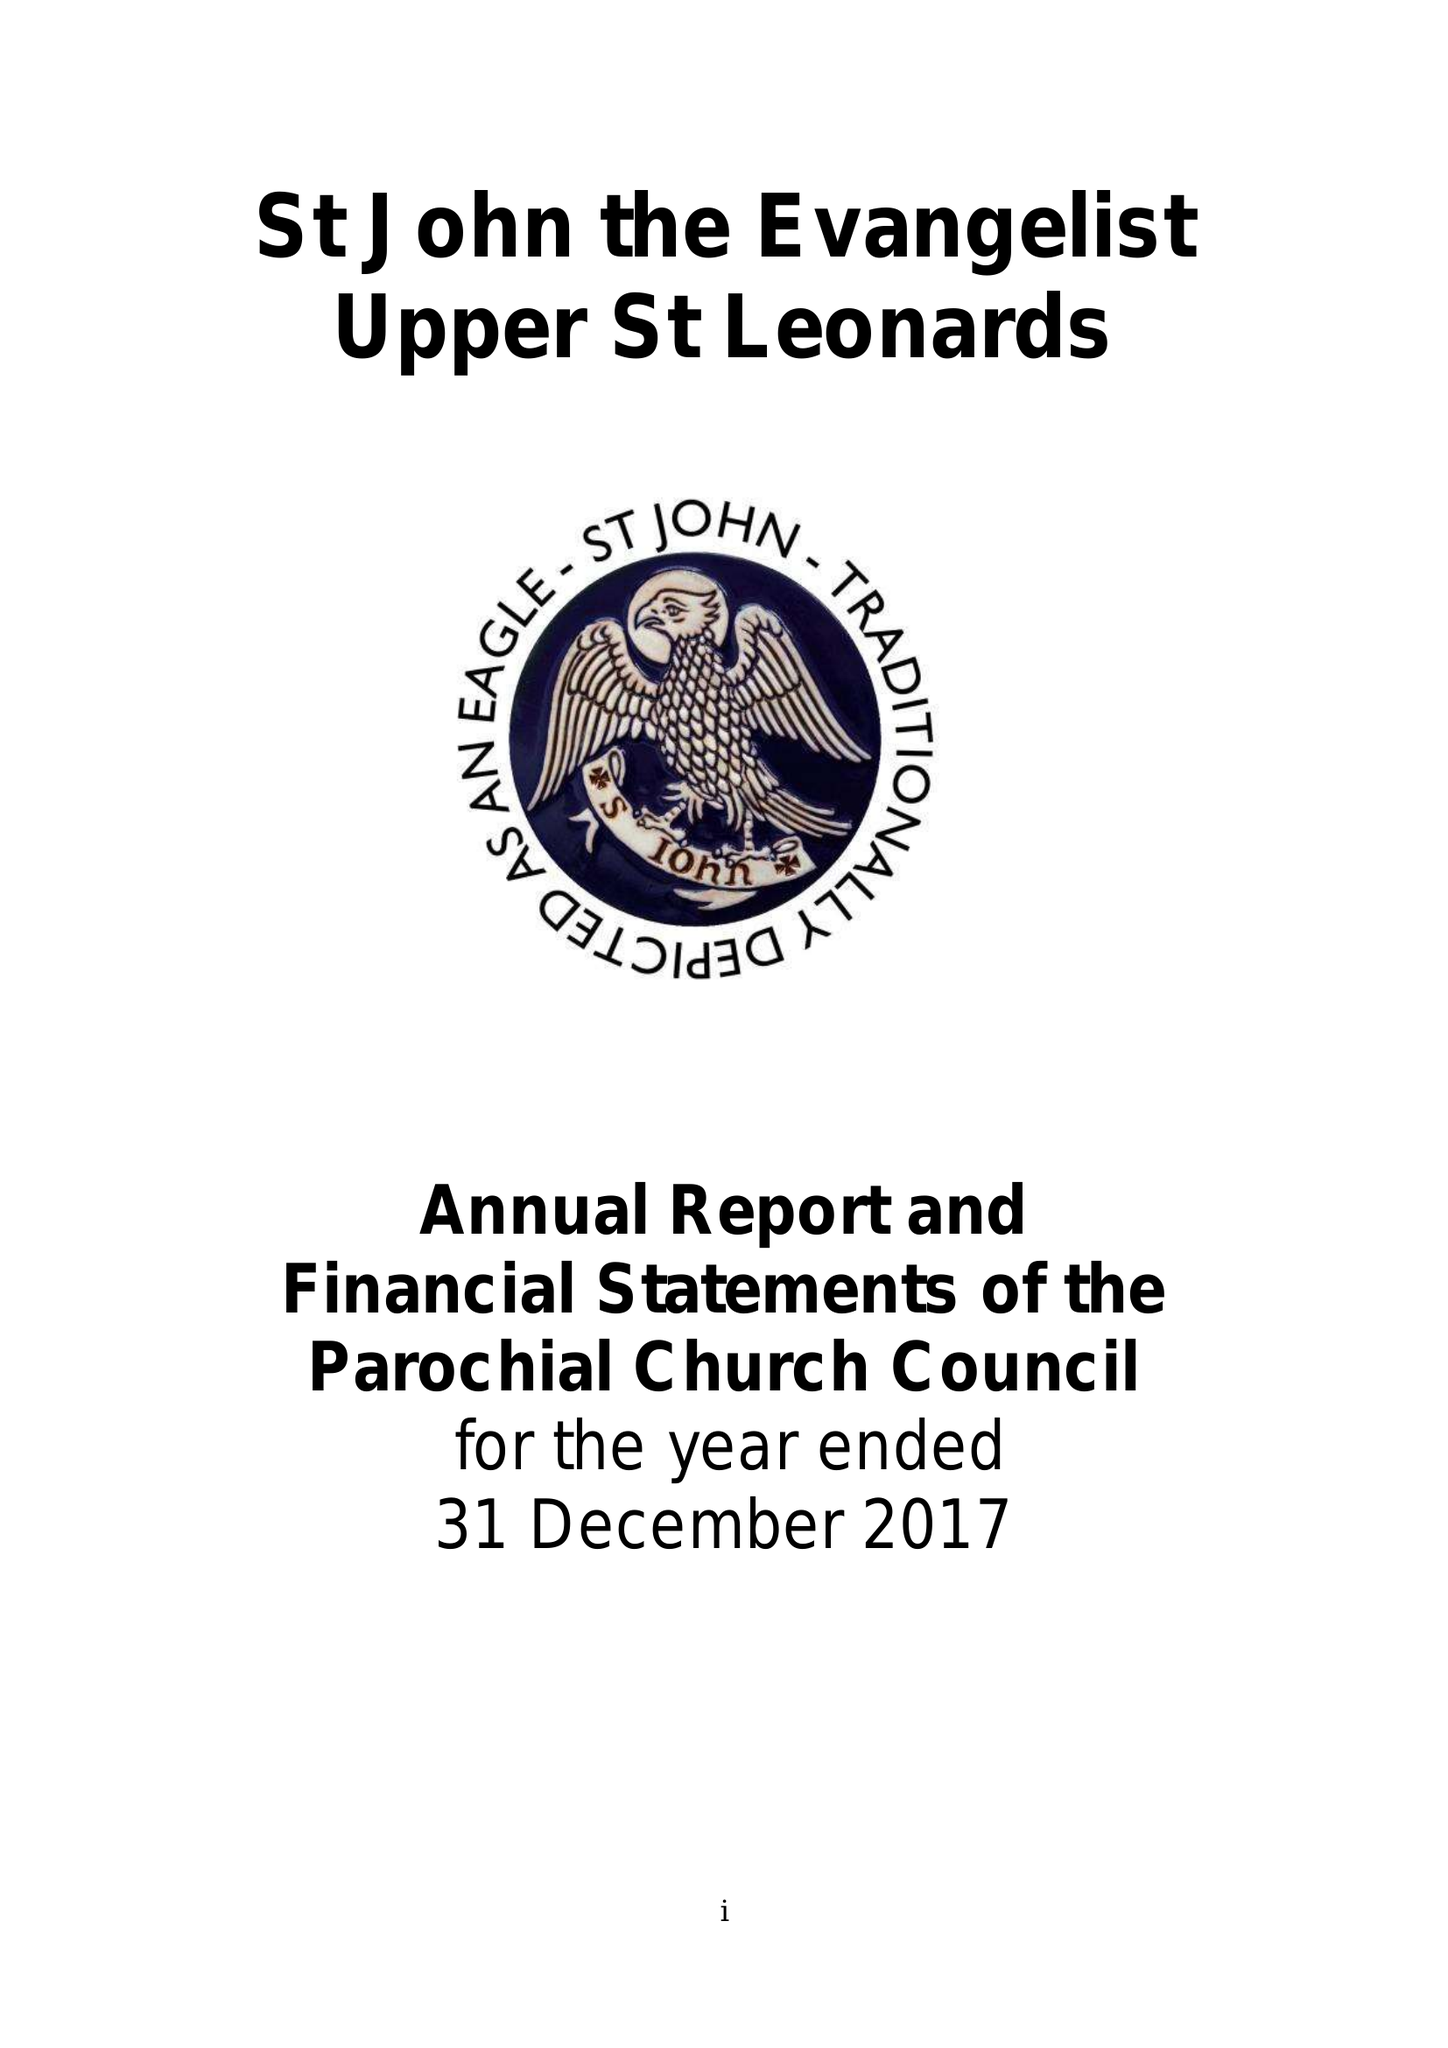What is the value for the spending_annually_in_british_pounds?
Answer the question using a single word or phrase. 145244.00 